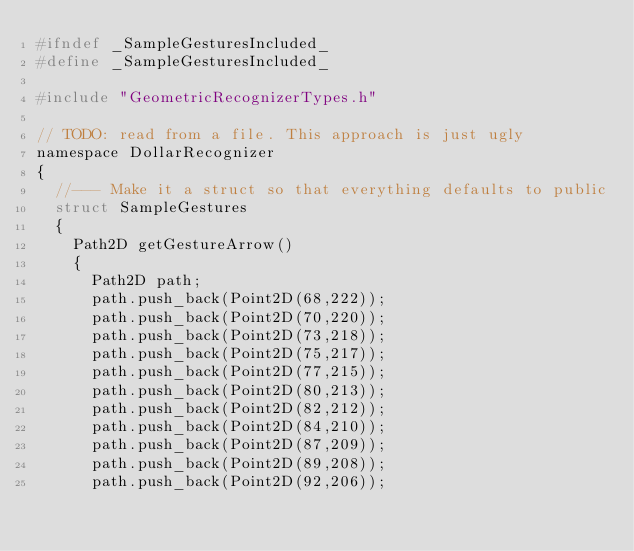<code> <loc_0><loc_0><loc_500><loc_500><_C_>#ifndef _SampleGesturesIncluded_
#define _SampleGesturesIncluded_

#include "GeometricRecognizerTypes.h"

// TODO: read from a file. This approach is just ugly
namespace DollarRecognizer
{
	//--- Make it a struct so that everything defaults to public
	struct SampleGestures
	{
		Path2D getGestureArrow()
		{
			Path2D path;
			path.push_back(Point2D(68,222));
			path.push_back(Point2D(70,220));
			path.push_back(Point2D(73,218));
			path.push_back(Point2D(75,217));
			path.push_back(Point2D(77,215));
			path.push_back(Point2D(80,213));
			path.push_back(Point2D(82,212));
			path.push_back(Point2D(84,210));
			path.push_back(Point2D(87,209));
			path.push_back(Point2D(89,208));
			path.push_back(Point2D(92,206));</code> 